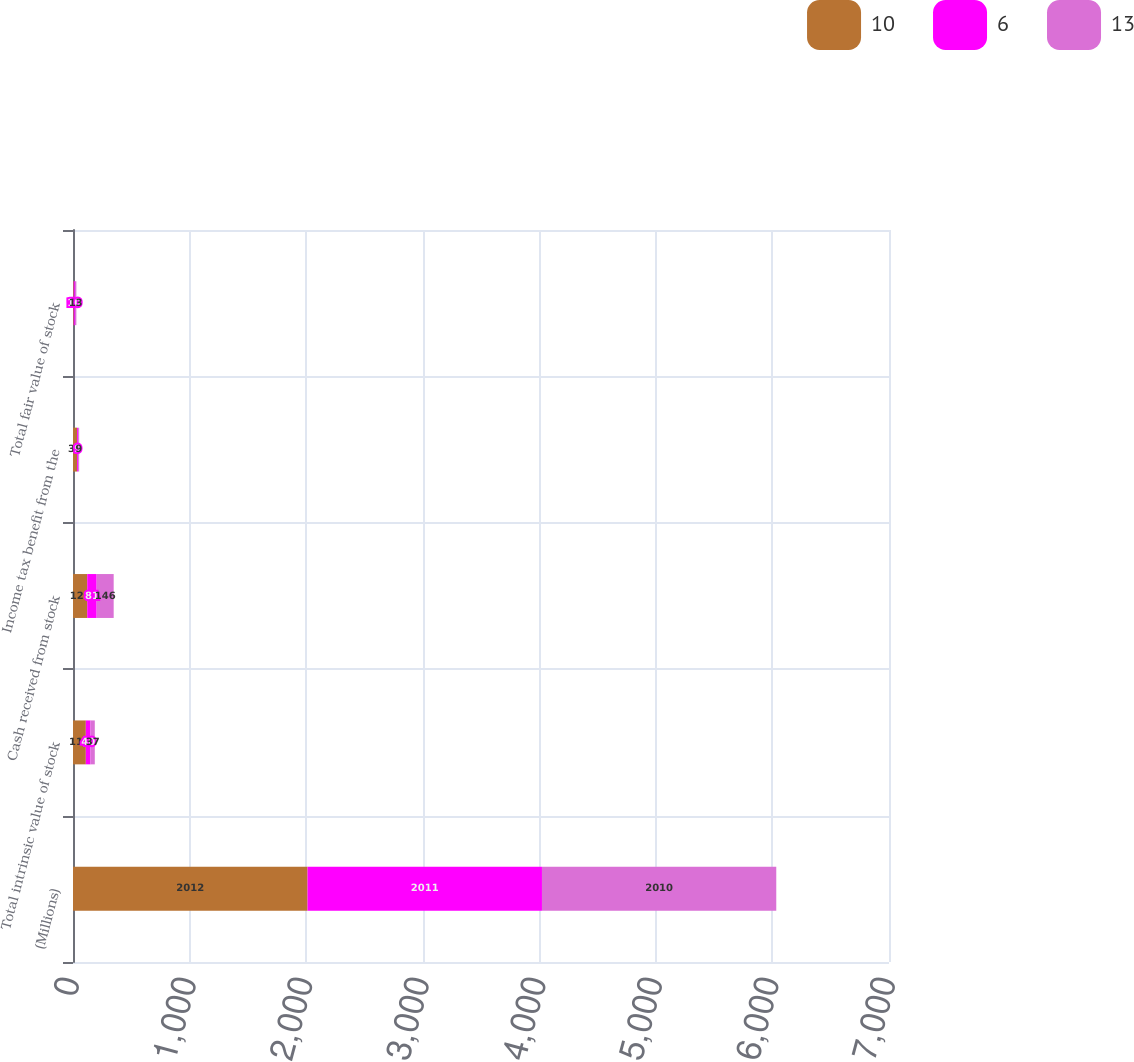Convert chart. <chart><loc_0><loc_0><loc_500><loc_500><stacked_bar_chart><ecel><fcel>(Millions)<fcel>Total intrinsic value of stock<fcel>Cash received from stock<fcel>Income tax benefit from the<fcel>Total fair value of stock<nl><fcel>10<fcel>2012<fcel>110<fcel>122<fcel>35<fcel>6<nl><fcel>6<fcel>2011<fcel>40<fcel>81<fcel>9<fcel>10<nl><fcel>13<fcel>2010<fcel>37<fcel>146<fcel>9<fcel>13<nl></chart> 